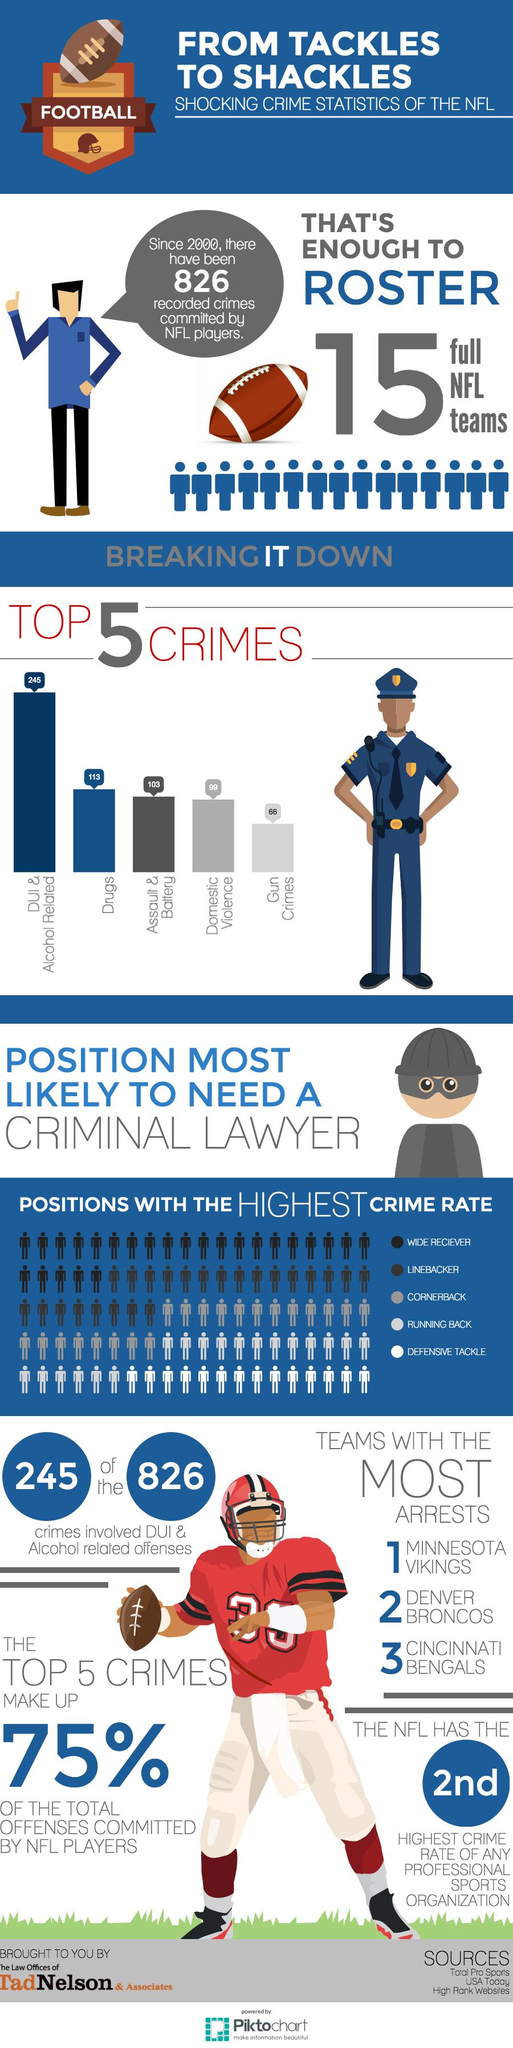Specify some key components in this picture. In the data set of player positions, wide receivers had the highest crime rate among all positions recorded. The number of crimes registered due to domestic violence was 113,103. Or was it 99? It is unclear. In 2020, the defensive tackle position recorded the lowest crime rate among all player positions. 